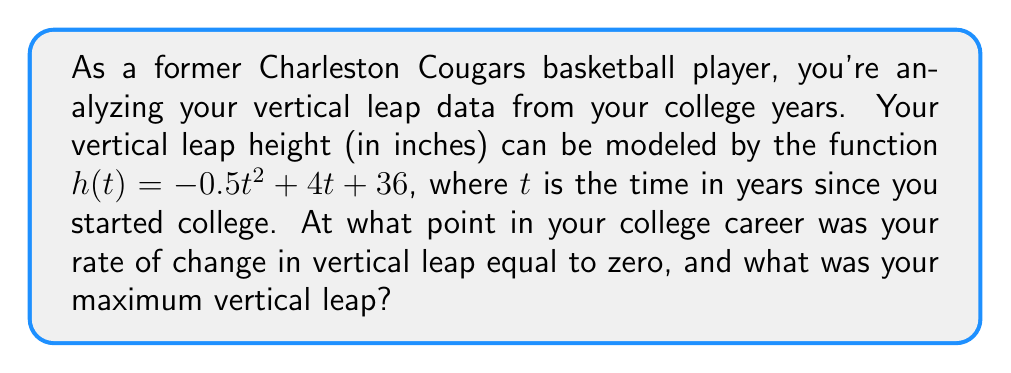Could you help me with this problem? 1) To find the rate of change of the vertical leap, we need to find the derivative of $h(t)$.
   $h'(t) = -t + 4$

2) The rate of change is zero when $h'(t) = 0$:
   $-t + 4 = 0$
   $-t = -4$
   $t = 4$

3) This occurs 4 years after starting college, which would be your senior year.

4) To find the maximum vertical leap, we substitute $t = 4$ into the original function:
   $h(4) = -0.5(4)^2 + 4(4) + 36$
   $= -0.5(16) + 16 + 36$
   $= -8 + 16 + 36$
   $= 44$

5) We can confirm this is a maximum by checking the second derivative:
   $h''(t) = -1$, which is negative, confirming a maximum.
Answer: Maximum vertical leap of 44 inches occurred 4 years after starting college. 